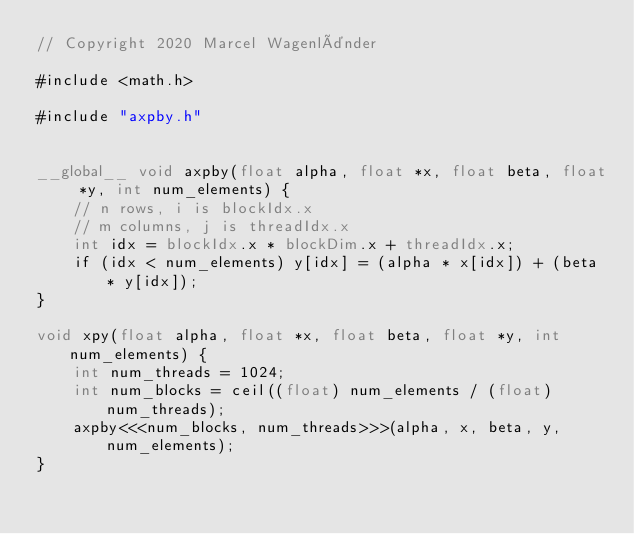Convert code to text. <code><loc_0><loc_0><loc_500><loc_500><_Cuda_>// Copyright 2020 Marcel Wagenländer

#include <math.h>

#include "axpby.h"


__global__ void axpby(float alpha, float *x, float beta, float *y, int num_elements) {
    // n rows, i is blockIdx.x
    // m columns, j is threadIdx.x
    int idx = blockIdx.x * blockDim.x + threadIdx.x;
    if (idx < num_elements) y[idx] = (alpha * x[idx]) + (beta * y[idx]);
}

void xpy(float alpha, float *x, float beta, float *y, int num_elements) {
    int num_threads = 1024;
    int num_blocks = ceil((float) num_elements / (float) num_threads);
    axpby<<<num_blocks, num_threads>>>(alpha, x, beta, y, num_elements);
}
</code> 